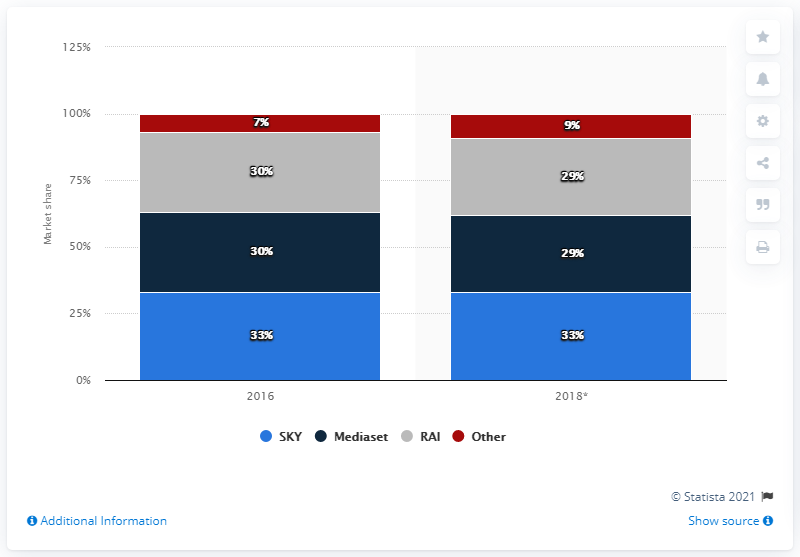Identify some key points in this picture. In 2016, the market share of the main television providers in Italy was significant. 